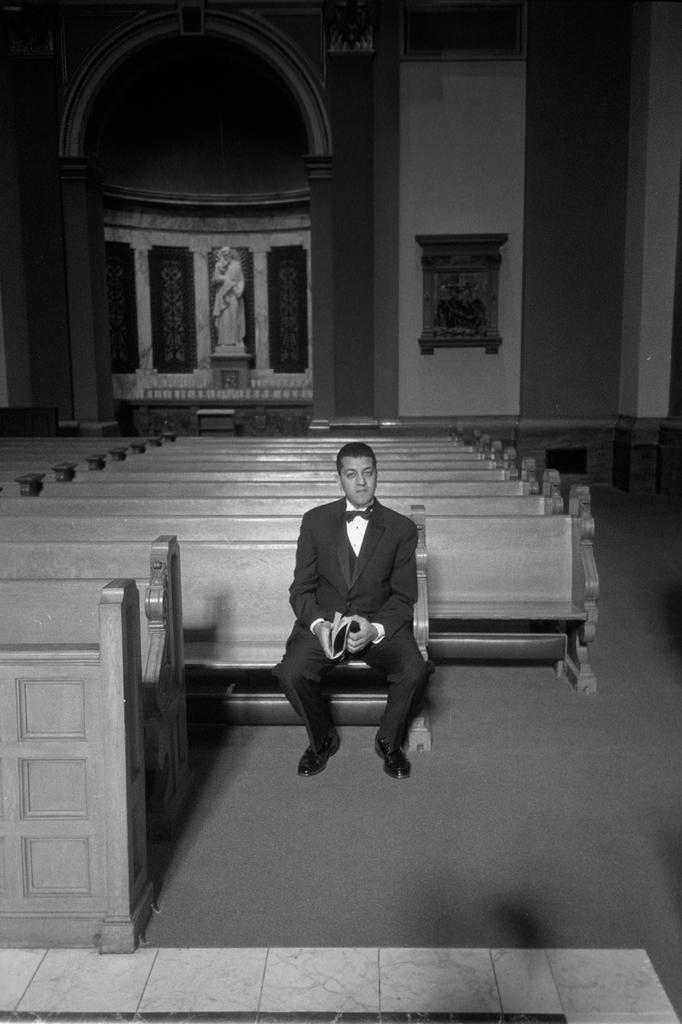Can you describe this image briefly? There is a black and white image. In this image, there is a person wearing clothes and sitting on the bench. There is a sculpture and benches in the middle of the image. 